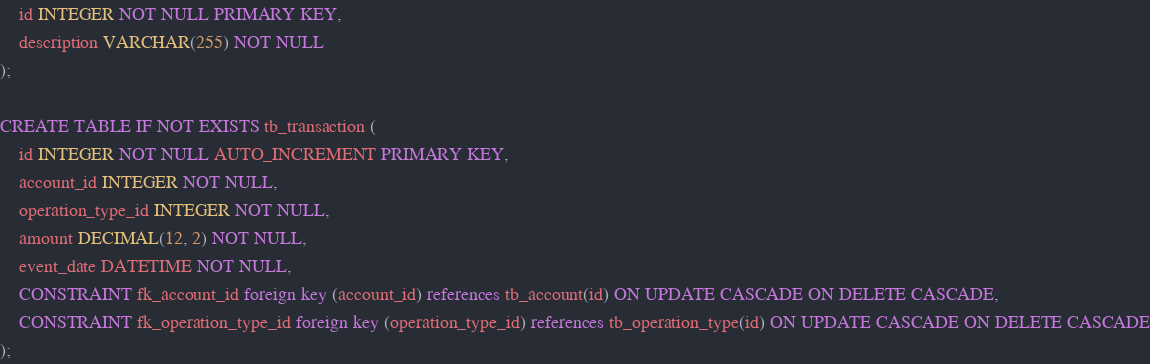Convert code to text. <code><loc_0><loc_0><loc_500><loc_500><_SQL_>    id INTEGER NOT NULL PRIMARY KEY,
    description VARCHAR(255) NOT NULL
);

CREATE TABLE IF NOT EXISTS tb_transaction (
    id INTEGER NOT NULL AUTO_INCREMENT PRIMARY KEY,
    account_id INTEGER NOT NULL,
    operation_type_id INTEGER NOT NULL,
    amount DECIMAL(12, 2) NOT NULL,
    event_date DATETIME NOT NULL,
    CONSTRAINT fk_account_id foreign key (account_id) references tb_account(id) ON UPDATE CASCADE ON DELETE CASCADE,
    CONSTRAINT fk_operation_type_id foreign key (operation_type_id) references tb_operation_type(id) ON UPDATE CASCADE ON DELETE CASCADE
);
</code> 